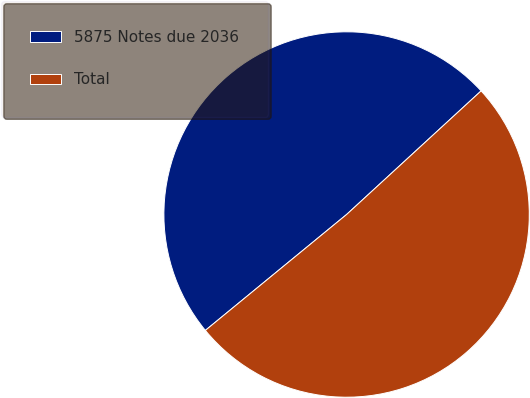Convert chart to OTSL. <chart><loc_0><loc_0><loc_500><loc_500><pie_chart><fcel>5875 Notes due 2036<fcel>Total<nl><fcel>49.11%<fcel>50.89%<nl></chart> 